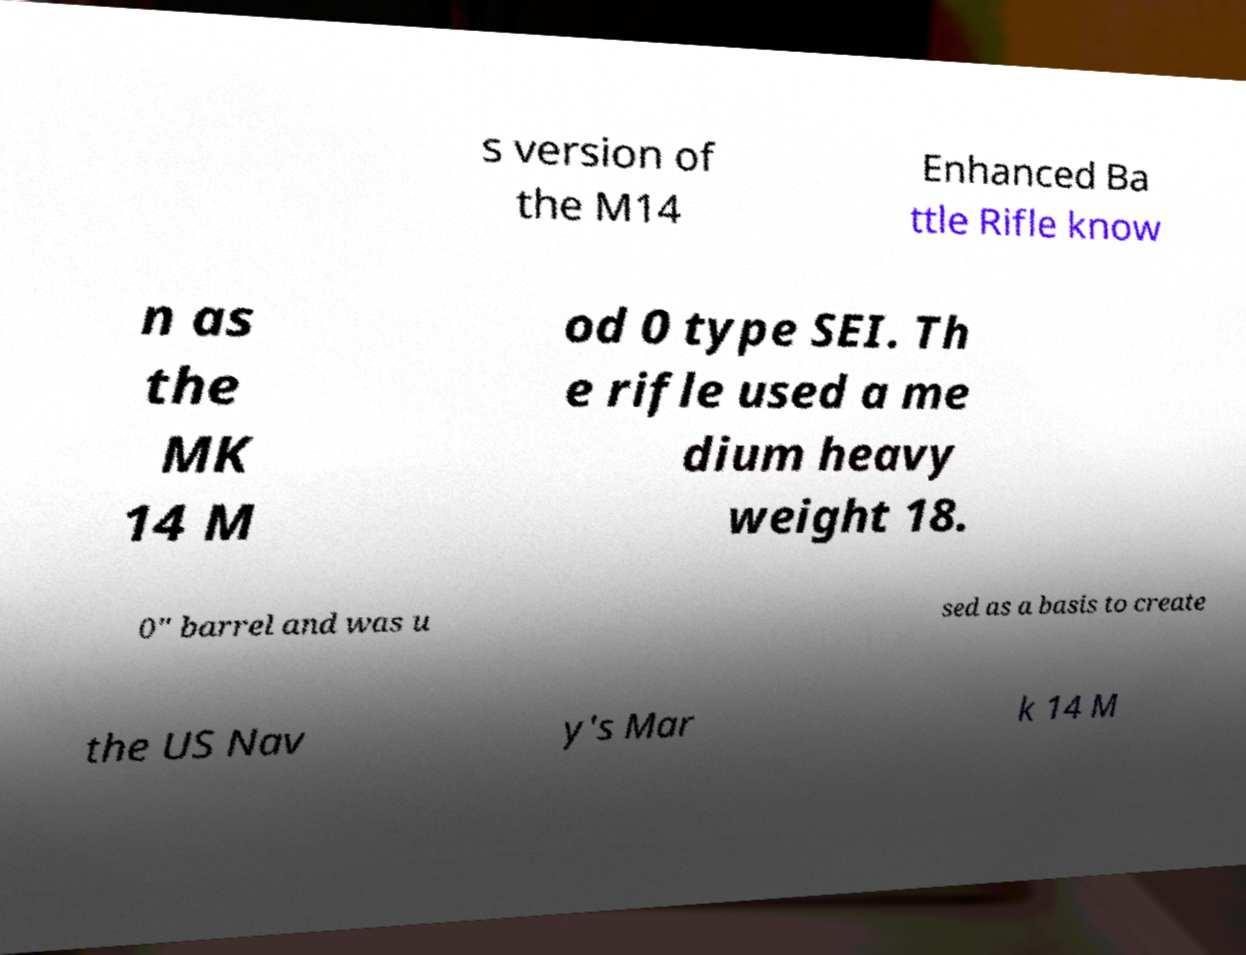For documentation purposes, I need the text within this image transcribed. Could you provide that? s version of the M14 Enhanced Ba ttle Rifle know n as the MK 14 M od 0 type SEI. Th e rifle used a me dium heavy weight 18. 0" barrel and was u sed as a basis to create the US Nav y's Mar k 14 M 